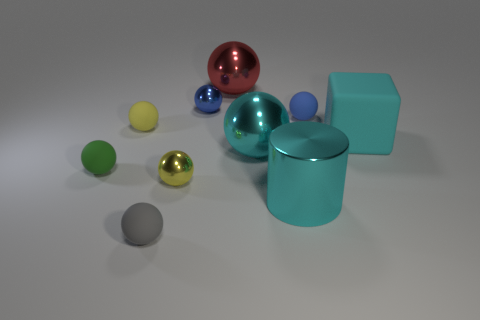Subtract all green spheres. How many spheres are left? 7 Subtract all small yellow spheres. How many spheres are left? 6 Subtract 2 spheres. How many spheres are left? 6 Subtract all green spheres. Subtract all brown cylinders. How many spheres are left? 7 Subtract all cylinders. How many objects are left? 9 Add 5 small yellow objects. How many small yellow objects are left? 7 Add 5 small blue things. How many small blue things exist? 7 Subtract 0 green cylinders. How many objects are left? 10 Subtract all small yellow matte things. Subtract all tiny green matte spheres. How many objects are left? 8 